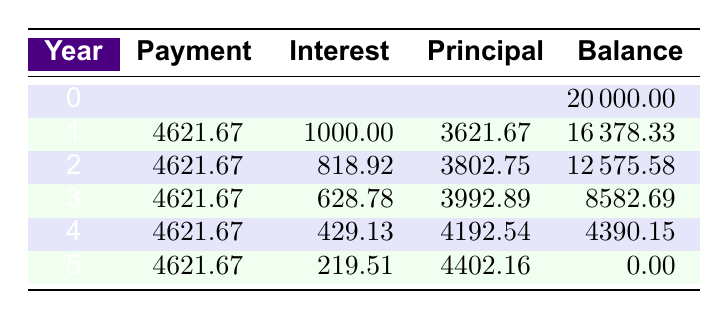What is the total amount paid in the first year? The payment in the first year is shown in the second row of the table, which is 4621.67.
Answer: 4621.67 How much interest is paid in the second year? The interest paid in the second year is shown in the third row of the table, which is 818.92.
Answer: 818.92 What is the total principal paid over the five years? To find the total principal, we sum the principal amounts over the five years: (3621.67 + 3802.75 + 3992.89 + 4192.54 + 4402.16) = 20011.01.
Answer: 20011.01 Is the interest payment in the fourth year greater than 400? The interest paid in the fourth year is 429.13, which is greater than 400.
Answer: Yes What is the balance after the third year? The balance after the third year is shown in the fourth row of the table, which is 8582.69.
Answer: 8582.69 What is the average payment made per year? The average payment can be calculated as the total payments over five years divided by 5. The total payment is 4621.67 * 5 = 23108.35, so the average payment is 23108.35 / 5 = 4621.67.
Answer: 4621.67 In which year is the principal payment the highest? The principal payments are listed in each row. The highest principal payment occurs in the fifth year, which is 4402.16.
Answer: Fifth year How much lower is the balance after the second year compared to the balance after the first year? The balance after the first year is 16378.33, and the balance after the second year is 12575.58. The difference is 16378.33 - 12575.58 = 3802.75.
Answer: 3802.75 Does the balance decrease consistently each year? The balances after each year are 20000.00, 16378.33, 12575.58, 8582.69, and 4390.15. The balance does decrease each year, indicating a consistent decrease.
Answer: Yes 